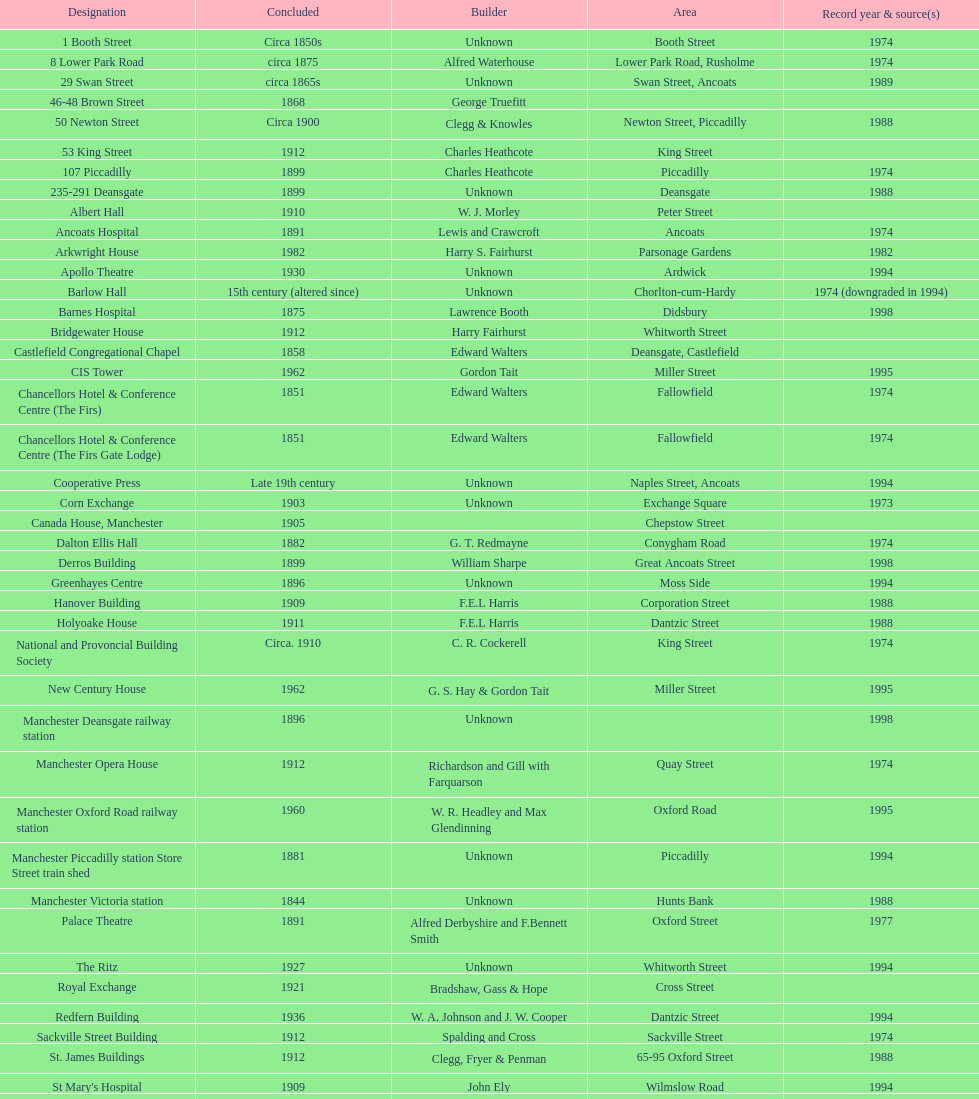How many buildings has the same year of listing as 1974? 15. 